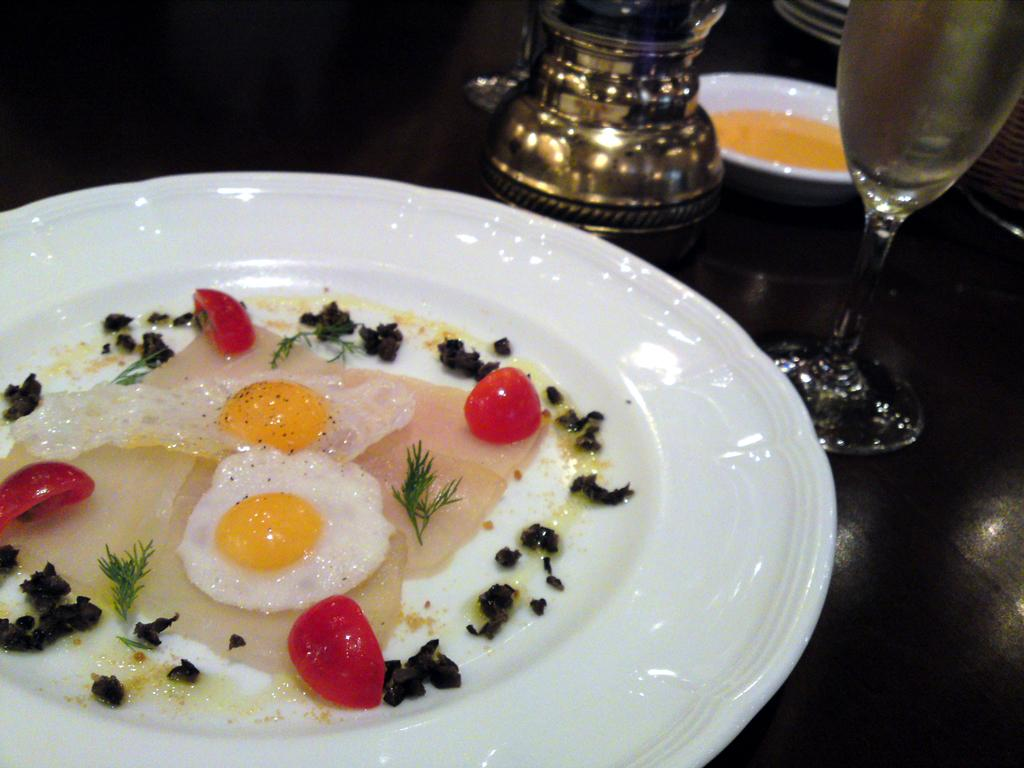What is on the plate in the image? There is food in a plate in the image. What else can be seen on the table besides the plate? There is a glass and a bowl with food on the right side of the image. Is there any other container visible on the table? Yes, there appears to be a jar on the table in the image. What type of structure can be seen in the background of the image? There is no structure visible in the background of the image. How many dogs are present in the image? There are no dogs present in the image. 